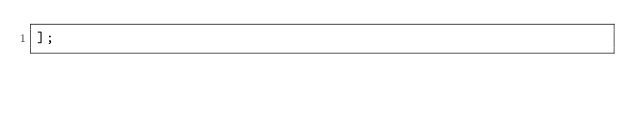<code> <loc_0><loc_0><loc_500><loc_500><_JavaScript_>];
</code> 